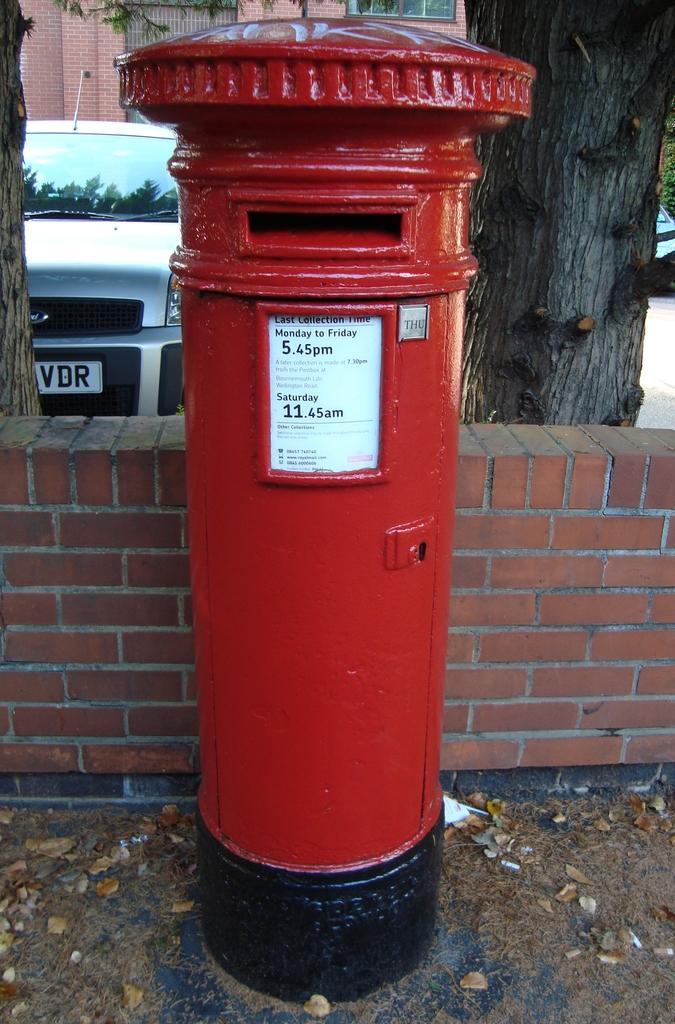Can you describe this image briefly? In this image there is a postbox in the middle. Behind the postbox there is a wall. In the background there is a car in the middle and there are two trees beside it. Behind the car there is a building. 